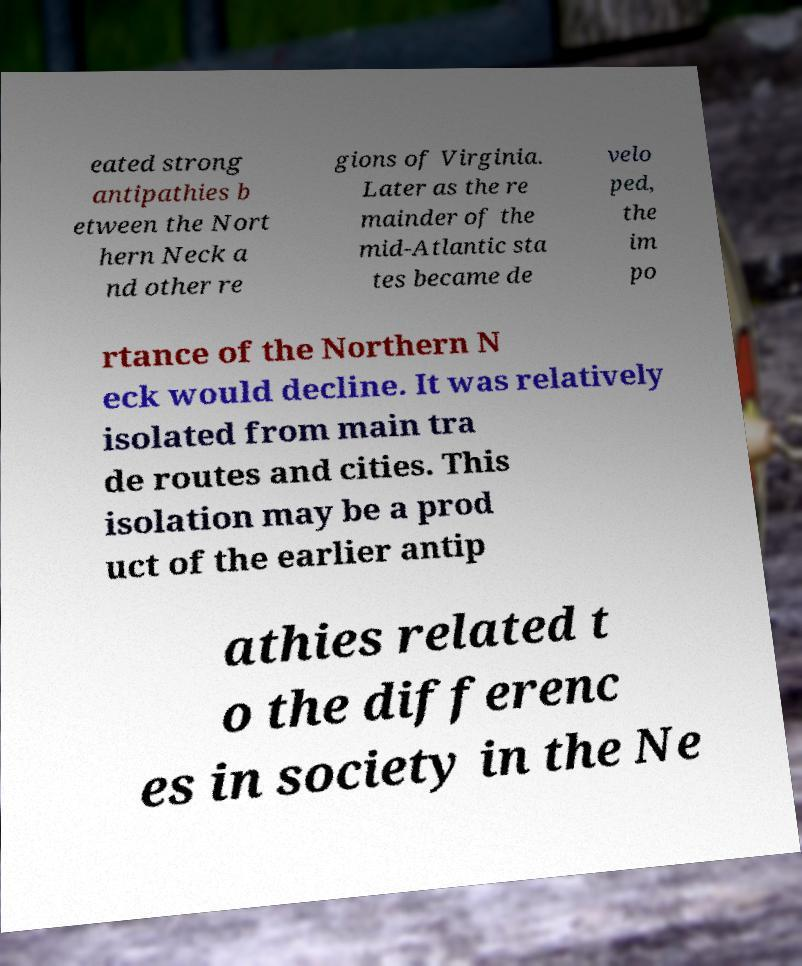I need the written content from this picture converted into text. Can you do that? eated strong antipathies b etween the Nort hern Neck a nd other re gions of Virginia. Later as the re mainder of the mid-Atlantic sta tes became de velo ped, the im po rtance of the Northern N eck would decline. It was relatively isolated from main tra de routes and cities. This isolation may be a prod uct of the earlier antip athies related t o the differenc es in society in the Ne 